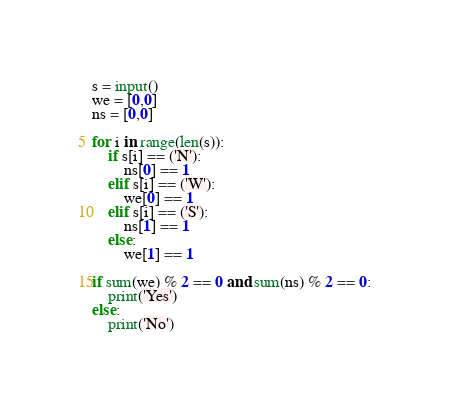<code> <loc_0><loc_0><loc_500><loc_500><_Python_>s = input()
we = [0,0]
ns = [0,0]

for i in range(len(s)):
    if s[i] == ('N'):
        ns[0] == 1
    elif s[i] == ('W'):
        we[0] == 1
    elif s[i] == ('S'):
        ns[1] == 1
    else:
        we[1] == 1

if sum(we) % 2 == 0 and sum(ns) % 2 == 0:
    print('Yes')
else:
    print('No')</code> 